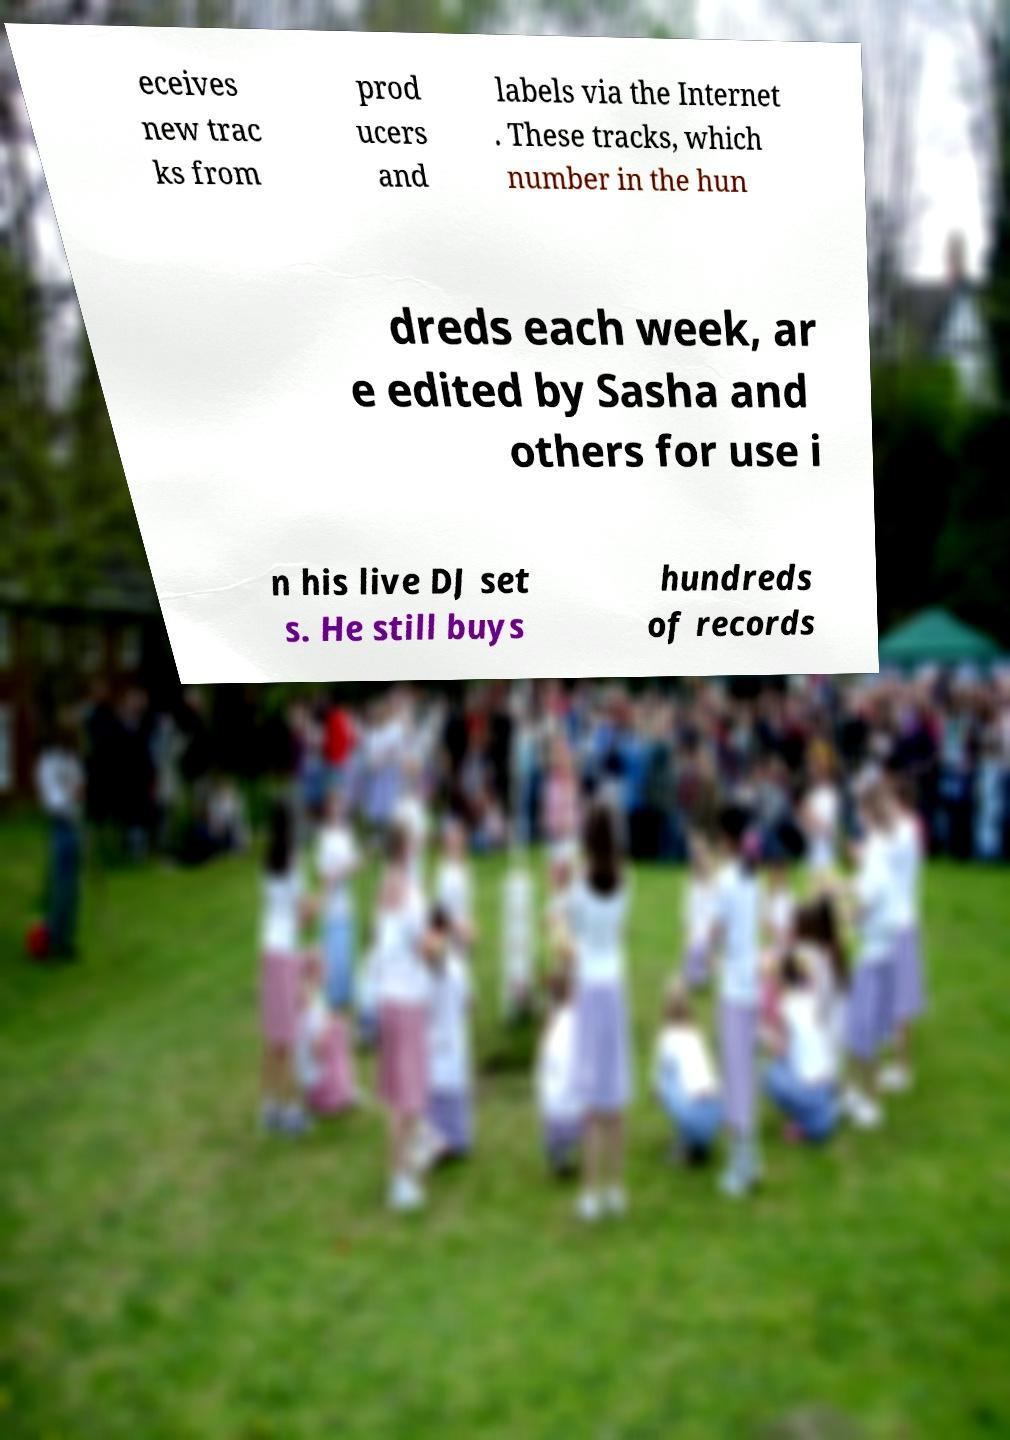Could you assist in decoding the text presented in this image and type it out clearly? eceives new trac ks from prod ucers and labels via the Internet . These tracks, which number in the hun dreds each week, ar e edited by Sasha and others for use i n his live DJ set s. He still buys hundreds of records 